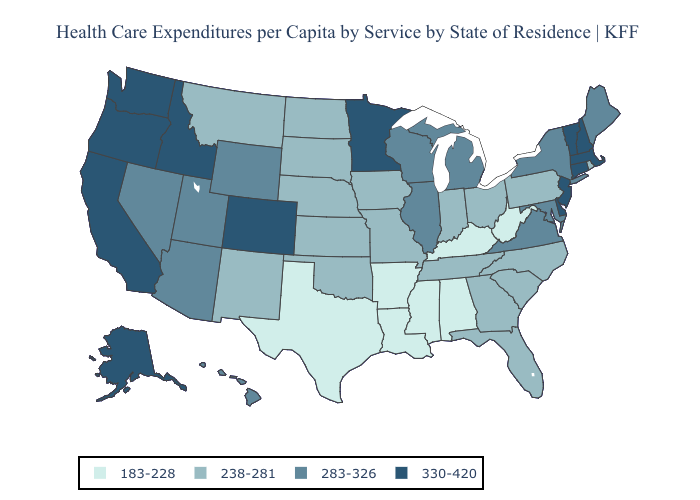Does Alabama have the lowest value in the South?
Quick response, please. Yes. Does Rhode Island have a higher value than North Dakota?
Concise answer only. No. Does Arkansas have a lower value than Louisiana?
Short answer required. No. Which states have the highest value in the USA?
Be succinct. Alaska, California, Colorado, Connecticut, Delaware, Idaho, Massachusetts, Minnesota, New Hampshire, New Jersey, Oregon, Vermont, Washington. Does Pennsylvania have the same value as Idaho?
Give a very brief answer. No. Which states hav the highest value in the South?
Quick response, please. Delaware. Name the states that have a value in the range 330-420?
Be succinct. Alaska, California, Colorado, Connecticut, Delaware, Idaho, Massachusetts, Minnesota, New Hampshire, New Jersey, Oregon, Vermont, Washington. Does Ohio have a higher value than South Carolina?
Keep it brief. No. Does the first symbol in the legend represent the smallest category?
Concise answer only. Yes. What is the lowest value in the USA?
Answer briefly. 183-228. How many symbols are there in the legend?
Short answer required. 4. Does Pennsylvania have the same value as Mississippi?
Give a very brief answer. No. What is the highest value in the West ?
Short answer required. 330-420. Which states hav the highest value in the West?
Quick response, please. Alaska, California, Colorado, Idaho, Oregon, Washington. Name the states that have a value in the range 238-281?
Answer briefly. Florida, Georgia, Indiana, Iowa, Kansas, Missouri, Montana, Nebraska, New Mexico, North Carolina, North Dakota, Ohio, Oklahoma, Pennsylvania, Rhode Island, South Carolina, South Dakota, Tennessee. 